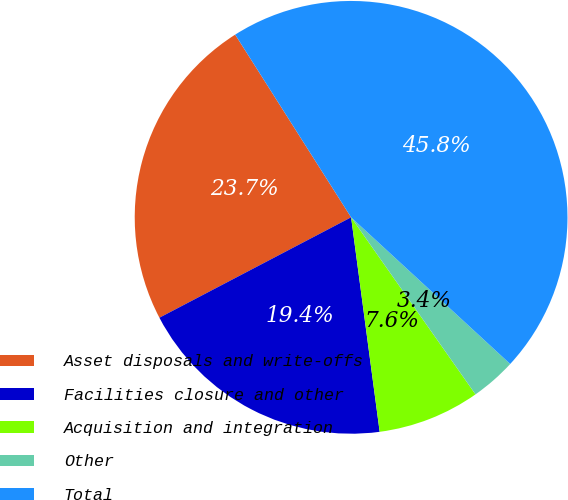Convert chart to OTSL. <chart><loc_0><loc_0><loc_500><loc_500><pie_chart><fcel>Asset disposals and write-offs<fcel>Facilities closure and other<fcel>Acquisition and integration<fcel>Other<fcel>Total<nl><fcel>23.68%<fcel>19.43%<fcel>7.64%<fcel>3.4%<fcel>45.85%<nl></chart> 